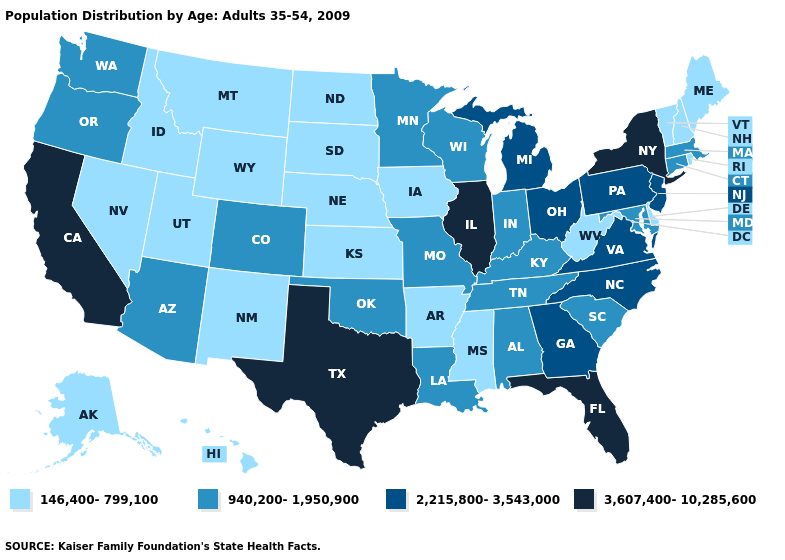Which states have the highest value in the USA?
Quick response, please. California, Florida, Illinois, New York, Texas. What is the value of California?
Keep it brief. 3,607,400-10,285,600. Which states have the lowest value in the USA?
Short answer required. Alaska, Arkansas, Delaware, Hawaii, Idaho, Iowa, Kansas, Maine, Mississippi, Montana, Nebraska, Nevada, New Hampshire, New Mexico, North Dakota, Rhode Island, South Dakota, Utah, Vermont, West Virginia, Wyoming. What is the value of Georgia?
Keep it brief. 2,215,800-3,543,000. What is the value of Delaware?
Be succinct. 146,400-799,100. What is the value of South Carolina?
Answer briefly. 940,200-1,950,900. What is the value of Wyoming?
Write a very short answer. 146,400-799,100. Is the legend a continuous bar?
Keep it brief. No. Among the states that border Rhode Island , which have the lowest value?
Be succinct. Connecticut, Massachusetts. Which states have the highest value in the USA?
Short answer required. California, Florida, Illinois, New York, Texas. What is the value of Wyoming?
Give a very brief answer. 146,400-799,100. Does Wyoming have the lowest value in the West?
Keep it brief. Yes. What is the highest value in the South ?
Answer briefly. 3,607,400-10,285,600. What is the value of Minnesota?
Keep it brief. 940,200-1,950,900. Name the states that have a value in the range 2,215,800-3,543,000?
Give a very brief answer. Georgia, Michigan, New Jersey, North Carolina, Ohio, Pennsylvania, Virginia. 